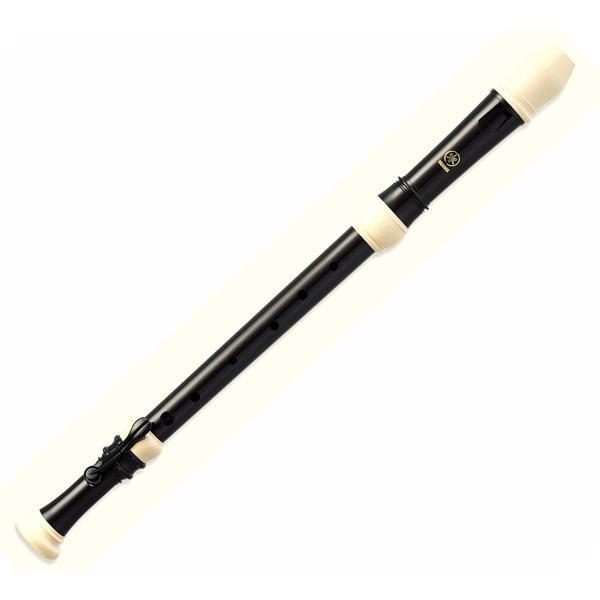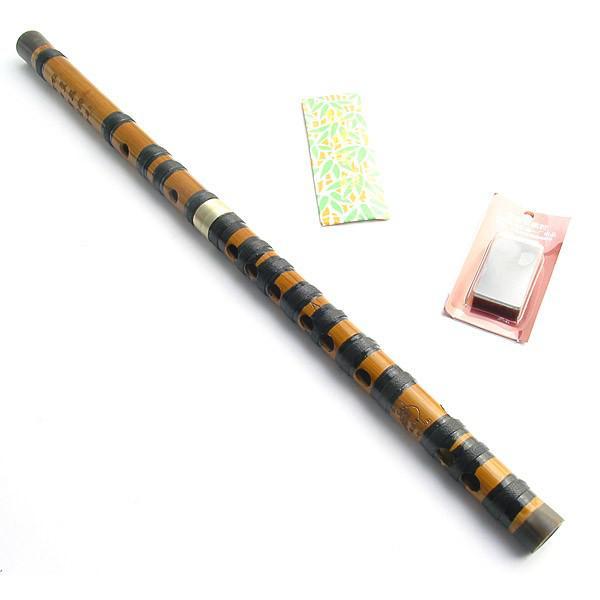The first image is the image on the left, the second image is the image on the right. Considering the images on both sides, is "There are exactly two flutes." valid? Answer yes or no. Yes. The first image is the image on the left, the second image is the image on the right. Considering the images on both sides, is "There is a total of two instruments." valid? Answer yes or no. Yes. 